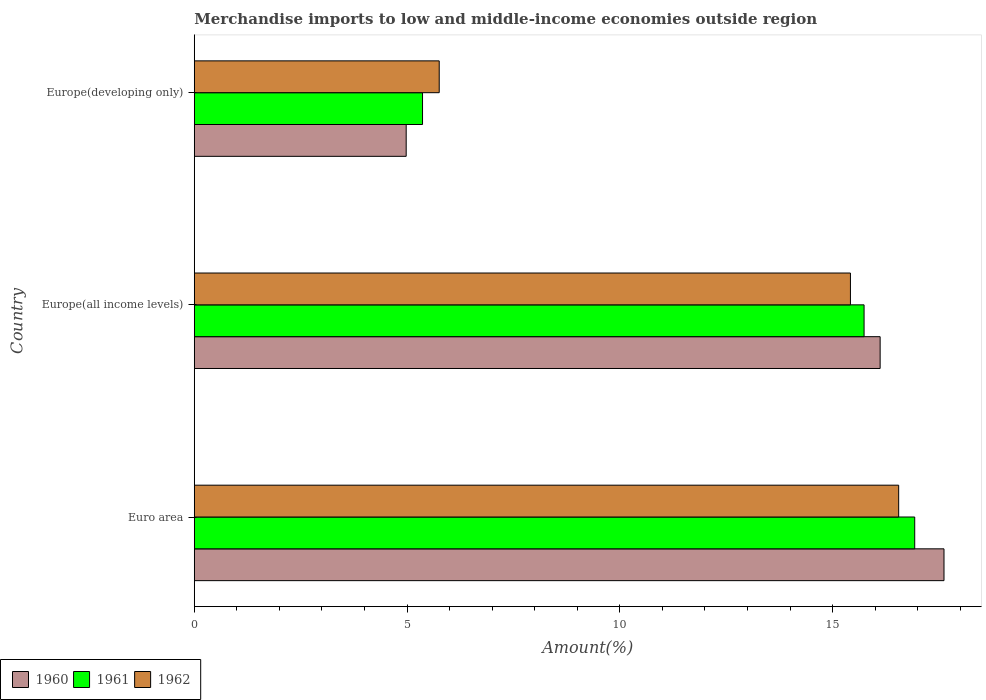Are the number of bars per tick equal to the number of legend labels?
Your answer should be very brief. Yes. What is the label of the 2nd group of bars from the top?
Provide a short and direct response. Europe(all income levels). What is the percentage of amount earned from merchandise imports in 1961 in Europe(developing only)?
Ensure brevity in your answer.  5.36. Across all countries, what is the maximum percentage of amount earned from merchandise imports in 1961?
Your response must be concise. 16.93. Across all countries, what is the minimum percentage of amount earned from merchandise imports in 1961?
Offer a very short reply. 5.36. In which country was the percentage of amount earned from merchandise imports in 1961 minimum?
Offer a terse response. Europe(developing only). What is the total percentage of amount earned from merchandise imports in 1960 in the graph?
Your answer should be very brief. 38.71. What is the difference between the percentage of amount earned from merchandise imports in 1961 in Europe(all income levels) and that in Europe(developing only)?
Provide a short and direct response. 10.38. What is the difference between the percentage of amount earned from merchandise imports in 1960 in Euro area and the percentage of amount earned from merchandise imports in 1962 in Europe(all income levels)?
Give a very brief answer. 2.2. What is the average percentage of amount earned from merchandise imports in 1962 per country?
Give a very brief answer. 12.58. What is the difference between the percentage of amount earned from merchandise imports in 1960 and percentage of amount earned from merchandise imports in 1961 in Euro area?
Make the answer very short. 0.69. What is the ratio of the percentage of amount earned from merchandise imports in 1960 in Europe(all income levels) to that in Europe(developing only)?
Offer a terse response. 3.24. What is the difference between the highest and the second highest percentage of amount earned from merchandise imports in 1960?
Give a very brief answer. 1.5. What is the difference between the highest and the lowest percentage of amount earned from merchandise imports in 1960?
Give a very brief answer. 12.64. What does the 1st bar from the top in Euro area represents?
Ensure brevity in your answer.  1962. How many bars are there?
Provide a succinct answer. 9. Are all the bars in the graph horizontal?
Offer a very short reply. Yes. Are the values on the major ticks of X-axis written in scientific E-notation?
Make the answer very short. No. Does the graph contain any zero values?
Your answer should be very brief. No. Does the graph contain grids?
Your response must be concise. No. Where does the legend appear in the graph?
Offer a terse response. Bottom left. How many legend labels are there?
Provide a succinct answer. 3. What is the title of the graph?
Provide a short and direct response. Merchandise imports to low and middle-income economies outside region. Does "1960" appear as one of the legend labels in the graph?
Your answer should be very brief. Yes. What is the label or title of the X-axis?
Offer a very short reply. Amount(%). What is the label or title of the Y-axis?
Provide a succinct answer. Country. What is the Amount(%) in 1960 in Euro area?
Provide a short and direct response. 17.62. What is the Amount(%) in 1961 in Euro area?
Your answer should be very brief. 16.93. What is the Amount(%) in 1962 in Euro area?
Your answer should be very brief. 16.55. What is the Amount(%) of 1960 in Europe(all income levels)?
Keep it short and to the point. 16.12. What is the Amount(%) of 1961 in Europe(all income levels)?
Provide a succinct answer. 15.74. What is the Amount(%) in 1962 in Europe(all income levels)?
Your answer should be very brief. 15.42. What is the Amount(%) of 1960 in Europe(developing only)?
Your response must be concise. 4.98. What is the Amount(%) in 1961 in Europe(developing only)?
Offer a very short reply. 5.36. What is the Amount(%) of 1962 in Europe(developing only)?
Your answer should be very brief. 5.76. Across all countries, what is the maximum Amount(%) in 1960?
Offer a very short reply. 17.62. Across all countries, what is the maximum Amount(%) of 1961?
Ensure brevity in your answer.  16.93. Across all countries, what is the maximum Amount(%) of 1962?
Your response must be concise. 16.55. Across all countries, what is the minimum Amount(%) of 1960?
Provide a succinct answer. 4.98. Across all countries, what is the minimum Amount(%) in 1961?
Offer a terse response. 5.36. Across all countries, what is the minimum Amount(%) of 1962?
Ensure brevity in your answer.  5.76. What is the total Amount(%) of 1960 in the graph?
Your answer should be compact. 38.71. What is the total Amount(%) in 1961 in the graph?
Keep it short and to the point. 38.03. What is the total Amount(%) of 1962 in the graph?
Offer a very short reply. 37.73. What is the difference between the Amount(%) of 1960 in Euro area and that in Europe(all income levels)?
Make the answer very short. 1.5. What is the difference between the Amount(%) of 1961 in Euro area and that in Europe(all income levels)?
Offer a terse response. 1.19. What is the difference between the Amount(%) in 1962 in Euro area and that in Europe(all income levels)?
Provide a succinct answer. 1.13. What is the difference between the Amount(%) in 1960 in Euro area and that in Europe(developing only)?
Make the answer very short. 12.64. What is the difference between the Amount(%) in 1961 in Euro area and that in Europe(developing only)?
Your answer should be compact. 11.57. What is the difference between the Amount(%) in 1962 in Euro area and that in Europe(developing only)?
Ensure brevity in your answer.  10.8. What is the difference between the Amount(%) in 1960 in Europe(all income levels) and that in Europe(developing only)?
Provide a short and direct response. 11.14. What is the difference between the Amount(%) in 1961 in Europe(all income levels) and that in Europe(developing only)?
Offer a terse response. 10.38. What is the difference between the Amount(%) in 1962 in Europe(all income levels) and that in Europe(developing only)?
Offer a terse response. 9.66. What is the difference between the Amount(%) of 1960 in Euro area and the Amount(%) of 1961 in Europe(all income levels)?
Give a very brief answer. 1.88. What is the difference between the Amount(%) in 1960 in Euro area and the Amount(%) in 1962 in Europe(all income levels)?
Ensure brevity in your answer.  2.2. What is the difference between the Amount(%) of 1961 in Euro area and the Amount(%) of 1962 in Europe(all income levels)?
Ensure brevity in your answer.  1.51. What is the difference between the Amount(%) of 1960 in Euro area and the Amount(%) of 1961 in Europe(developing only)?
Your answer should be compact. 12.25. What is the difference between the Amount(%) of 1960 in Euro area and the Amount(%) of 1962 in Europe(developing only)?
Make the answer very short. 11.86. What is the difference between the Amount(%) in 1961 in Euro area and the Amount(%) in 1962 in Europe(developing only)?
Give a very brief answer. 11.17. What is the difference between the Amount(%) of 1960 in Europe(all income levels) and the Amount(%) of 1961 in Europe(developing only)?
Make the answer very short. 10.75. What is the difference between the Amount(%) of 1960 in Europe(all income levels) and the Amount(%) of 1962 in Europe(developing only)?
Provide a short and direct response. 10.36. What is the difference between the Amount(%) in 1961 in Europe(all income levels) and the Amount(%) in 1962 in Europe(developing only)?
Offer a very short reply. 9.98. What is the average Amount(%) in 1960 per country?
Your answer should be very brief. 12.9. What is the average Amount(%) in 1961 per country?
Give a very brief answer. 12.68. What is the average Amount(%) of 1962 per country?
Ensure brevity in your answer.  12.58. What is the difference between the Amount(%) in 1960 and Amount(%) in 1961 in Euro area?
Keep it short and to the point. 0.69. What is the difference between the Amount(%) in 1960 and Amount(%) in 1962 in Euro area?
Your response must be concise. 1.07. What is the difference between the Amount(%) of 1961 and Amount(%) of 1962 in Euro area?
Give a very brief answer. 0.38. What is the difference between the Amount(%) in 1960 and Amount(%) in 1961 in Europe(all income levels)?
Offer a very short reply. 0.38. What is the difference between the Amount(%) in 1960 and Amount(%) in 1962 in Europe(all income levels)?
Your response must be concise. 0.7. What is the difference between the Amount(%) of 1961 and Amount(%) of 1962 in Europe(all income levels)?
Your answer should be very brief. 0.32. What is the difference between the Amount(%) of 1960 and Amount(%) of 1961 in Europe(developing only)?
Provide a short and direct response. -0.38. What is the difference between the Amount(%) in 1960 and Amount(%) in 1962 in Europe(developing only)?
Make the answer very short. -0.78. What is the difference between the Amount(%) in 1961 and Amount(%) in 1962 in Europe(developing only)?
Offer a terse response. -0.39. What is the ratio of the Amount(%) in 1960 in Euro area to that in Europe(all income levels)?
Offer a terse response. 1.09. What is the ratio of the Amount(%) of 1961 in Euro area to that in Europe(all income levels)?
Provide a short and direct response. 1.08. What is the ratio of the Amount(%) of 1962 in Euro area to that in Europe(all income levels)?
Provide a succinct answer. 1.07. What is the ratio of the Amount(%) of 1960 in Euro area to that in Europe(developing only)?
Your response must be concise. 3.54. What is the ratio of the Amount(%) in 1961 in Euro area to that in Europe(developing only)?
Ensure brevity in your answer.  3.16. What is the ratio of the Amount(%) in 1962 in Euro area to that in Europe(developing only)?
Keep it short and to the point. 2.88. What is the ratio of the Amount(%) in 1960 in Europe(all income levels) to that in Europe(developing only)?
Offer a terse response. 3.24. What is the ratio of the Amount(%) in 1961 in Europe(all income levels) to that in Europe(developing only)?
Your answer should be compact. 2.93. What is the ratio of the Amount(%) of 1962 in Europe(all income levels) to that in Europe(developing only)?
Make the answer very short. 2.68. What is the difference between the highest and the second highest Amount(%) of 1960?
Ensure brevity in your answer.  1.5. What is the difference between the highest and the second highest Amount(%) of 1961?
Offer a very short reply. 1.19. What is the difference between the highest and the second highest Amount(%) in 1962?
Your answer should be compact. 1.13. What is the difference between the highest and the lowest Amount(%) of 1960?
Your answer should be very brief. 12.64. What is the difference between the highest and the lowest Amount(%) of 1961?
Your answer should be compact. 11.57. What is the difference between the highest and the lowest Amount(%) in 1962?
Your answer should be compact. 10.8. 